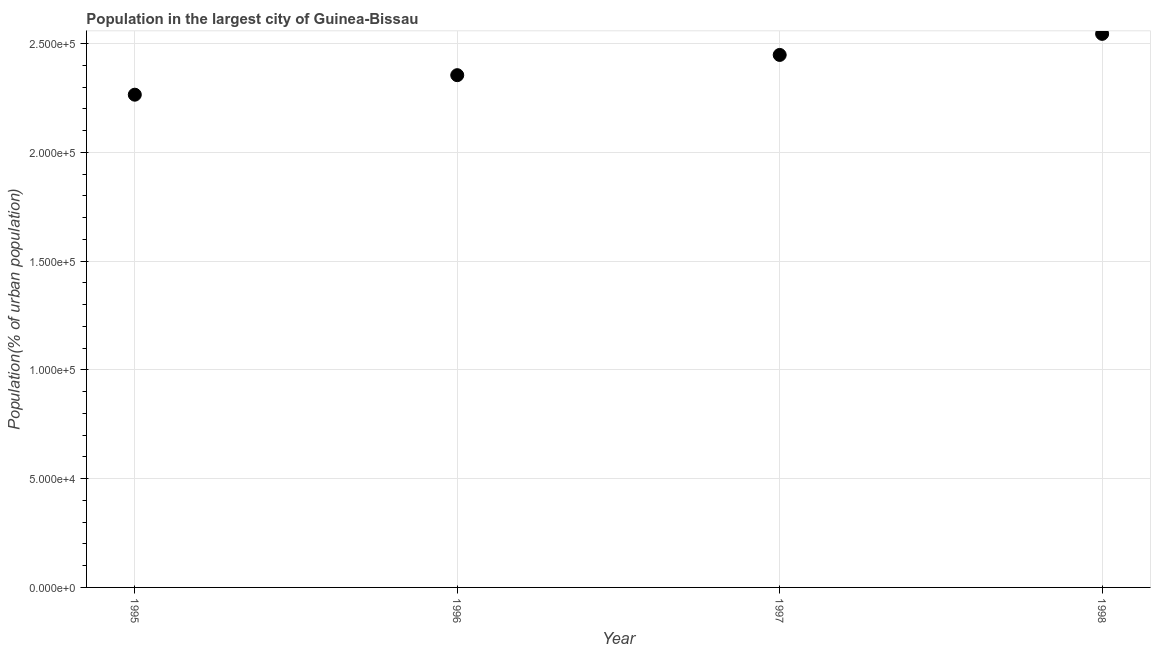What is the population in largest city in 1995?
Provide a short and direct response. 2.27e+05. Across all years, what is the maximum population in largest city?
Your answer should be compact. 2.55e+05. Across all years, what is the minimum population in largest city?
Your answer should be very brief. 2.27e+05. In which year was the population in largest city minimum?
Keep it short and to the point. 1995. What is the sum of the population in largest city?
Give a very brief answer. 9.61e+05. What is the difference between the population in largest city in 1996 and 1998?
Offer a terse response. -1.90e+04. What is the average population in largest city per year?
Provide a succinct answer. 2.40e+05. What is the median population in largest city?
Provide a short and direct response. 2.40e+05. What is the ratio of the population in largest city in 1996 to that in 1998?
Provide a short and direct response. 0.93. Is the difference between the population in largest city in 1995 and 1998 greater than the difference between any two years?
Offer a terse response. Yes. What is the difference between the highest and the second highest population in largest city?
Your answer should be very brief. 9686. Is the sum of the population in largest city in 1996 and 1997 greater than the maximum population in largest city across all years?
Give a very brief answer. Yes. What is the difference between the highest and the lowest population in largest city?
Give a very brief answer. 2.80e+04. Does the population in largest city monotonically increase over the years?
Provide a short and direct response. Yes. How many dotlines are there?
Make the answer very short. 1. What is the difference between two consecutive major ticks on the Y-axis?
Your answer should be very brief. 5.00e+04. Are the values on the major ticks of Y-axis written in scientific E-notation?
Offer a very short reply. Yes. What is the title of the graph?
Make the answer very short. Population in the largest city of Guinea-Bissau. What is the label or title of the Y-axis?
Your response must be concise. Population(% of urban population). What is the Population(% of urban population) in 1995?
Provide a short and direct response. 2.27e+05. What is the Population(% of urban population) in 1996?
Your response must be concise. 2.36e+05. What is the Population(% of urban population) in 1997?
Offer a terse response. 2.45e+05. What is the Population(% of urban population) in 1998?
Make the answer very short. 2.55e+05. What is the difference between the Population(% of urban population) in 1995 and 1996?
Your response must be concise. -8974. What is the difference between the Population(% of urban population) in 1995 and 1997?
Offer a very short reply. -1.83e+04. What is the difference between the Population(% of urban population) in 1995 and 1998?
Offer a very short reply. -2.80e+04. What is the difference between the Population(% of urban population) in 1996 and 1997?
Keep it short and to the point. -9304. What is the difference between the Population(% of urban population) in 1996 and 1998?
Your answer should be very brief. -1.90e+04. What is the difference between the Population(% of urban population) in 1997 and 1998?
Make the answer very short. -9686. What is the ratio of the Population(% of urban population) in 1995 to that in 1997?
Offer a very short reply. 0.93. What is the ratio of the Population(% of urban population) in 1995 to that in 1998?
Offer a terse response. 0.89. What is the ratio of the Population(% of urban population) in 1996 to that in 1998?
Make the answer very short. 0.93. 